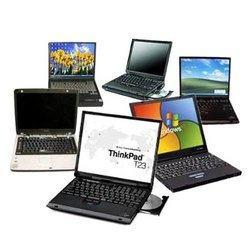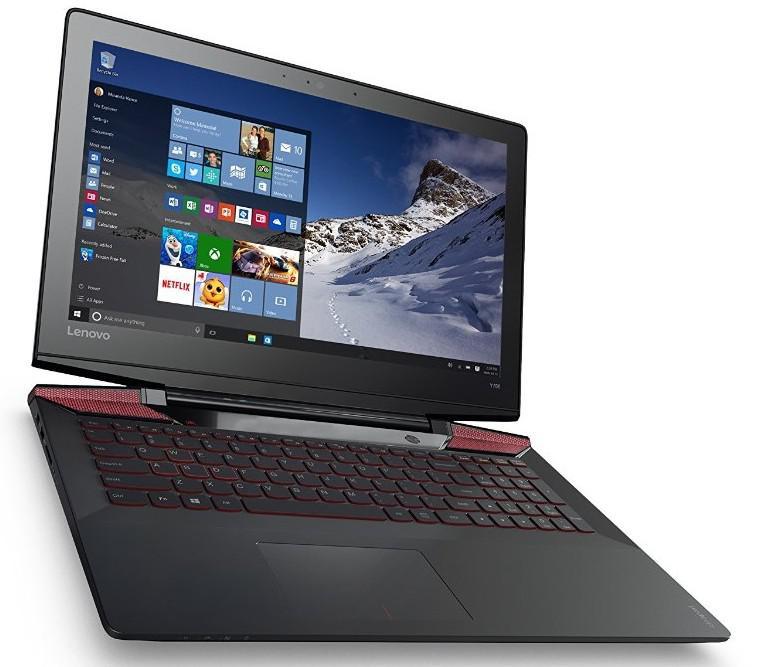The first image is the image on the left, the second image is the image on the right. Evaluate the accuracy of this statement regarding the images: "There are at least 3 laptops in the image on the left.". Is it true? Answer yes or no. Yes. The first image is the image on the left, the second image is the image on the right. For the images displayed, is the sentence "In at least one image there is a single laptop with a blue full screen touch menu." factually correct? Answer yes or no. No. 